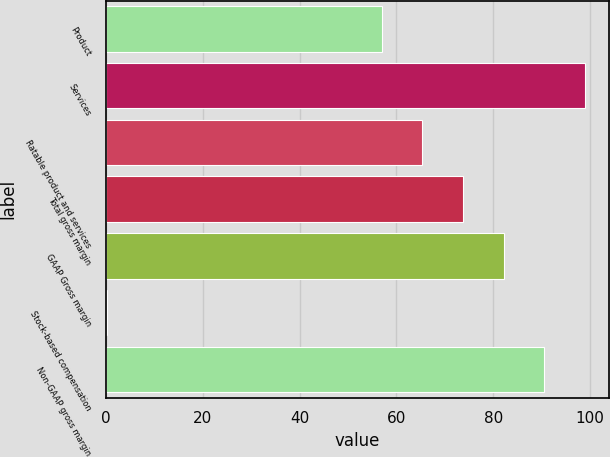Convert chart to OTSL. <chart><loc_0><loc_0><loc_500><loc_500><bar_chart><fcel>Product<fcel>Services<fcel>Ratable product and services<fcel>Total gross margin<fcel>GAAP Gross margin<fcel>Stock-based compensation<fcel>Non-GAAP gross margin<nl><fcel>57<fcel>98.85<fcel>65.37<fcel>73.74<fcel>82.11<fcel>0.3<fcel>90.48<nl></chart> 